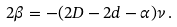Convert formula to latex. <formula><loc_0><loc_0><loc_500><loc_500>2 \beta = - ( 2 D - 2 d - \alpha ) \nu \, .</formula> 